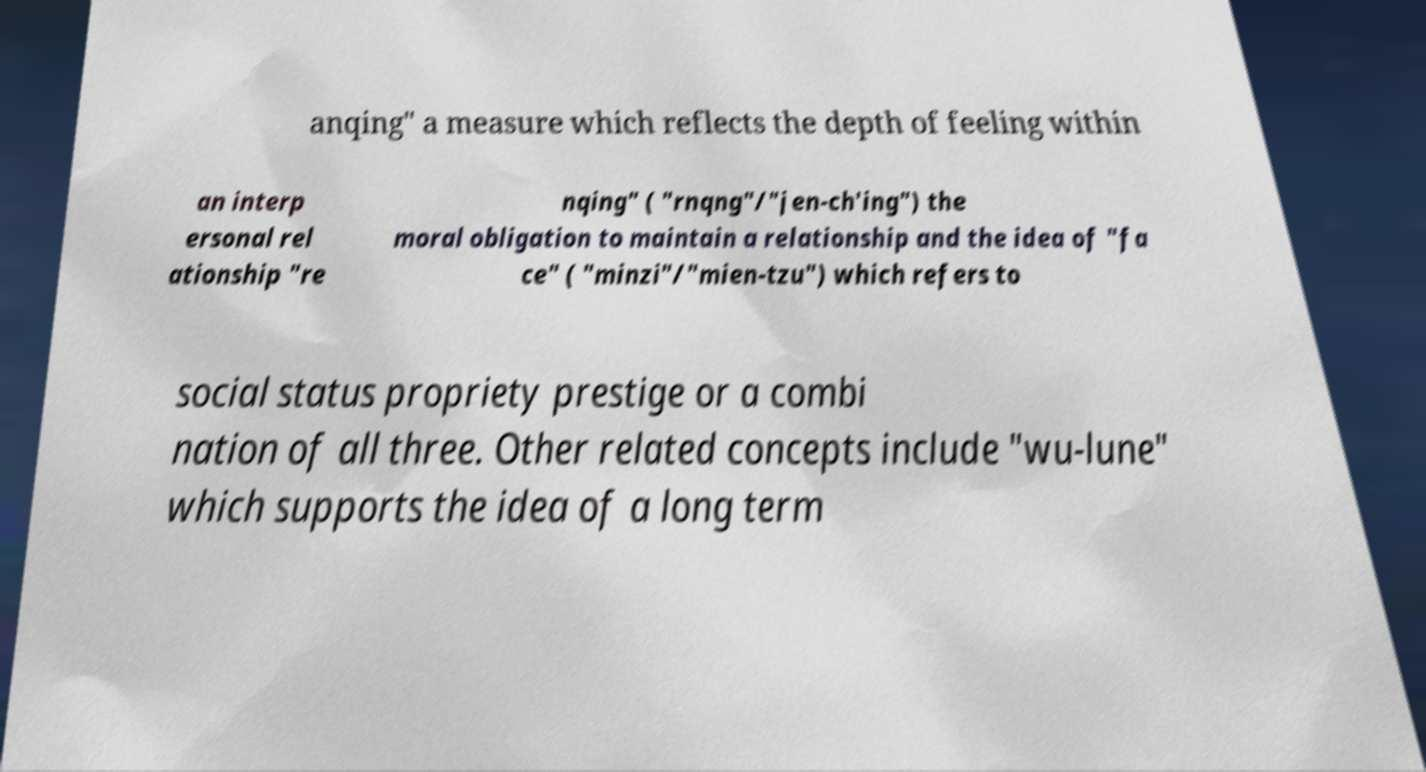For documentation purposes, I need the text within this image transcribed. Could you provide that? anqing" a measure which reflects the depth of feeling within an interp ersonal rel ationship "re nqing" ( "rnqng"/"jen-ch'ing") the moral obligation to maintain a relationship and the idea of "fa ce" ( "minzi"/"mien-tzu") which refers to social status propriety prestige or a combi nation of all three. Other related concepts include "wu-lune" which supports the idea of a long term 